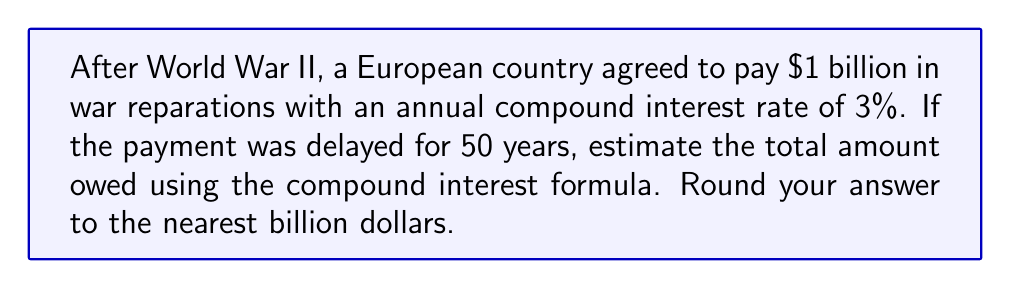Can you answer this question? To solve this problem, we'll use the compound interest formula:

$$A = P(1 + r)^t$$

Where:
$A$ = Final amount
$P$ = Principal (initial amount)
$r$ = Annual interest rate (in decimal form)
$t$ = Time in years

Given:
$P = \$1,000,000,000$ (1 billion dollars)
$r = 0.03$ (3% converted to decimal)
$t = 50$ years

Let's substitute these values into the formula:

$$A = 1,000,000,000(1 + 0.03)^{50}$$

Now, let's calculate:

1) First, compute $(1 + 0.03)^{50}$:
   $$(1.03)^{50} \approx 4.3839$$

2) Multiply this by the principal:
   $$1,000,000,000 \times 4.3839 \approx 4,383,900,000$$

3) Round to the nearest billion:
   $$4,383,900,000 \approx 4,384,000,000$$

Therefore, the estimated total amount owed after 50 years would be approximately $4.384 billion.
Answer: $4.384 billion 